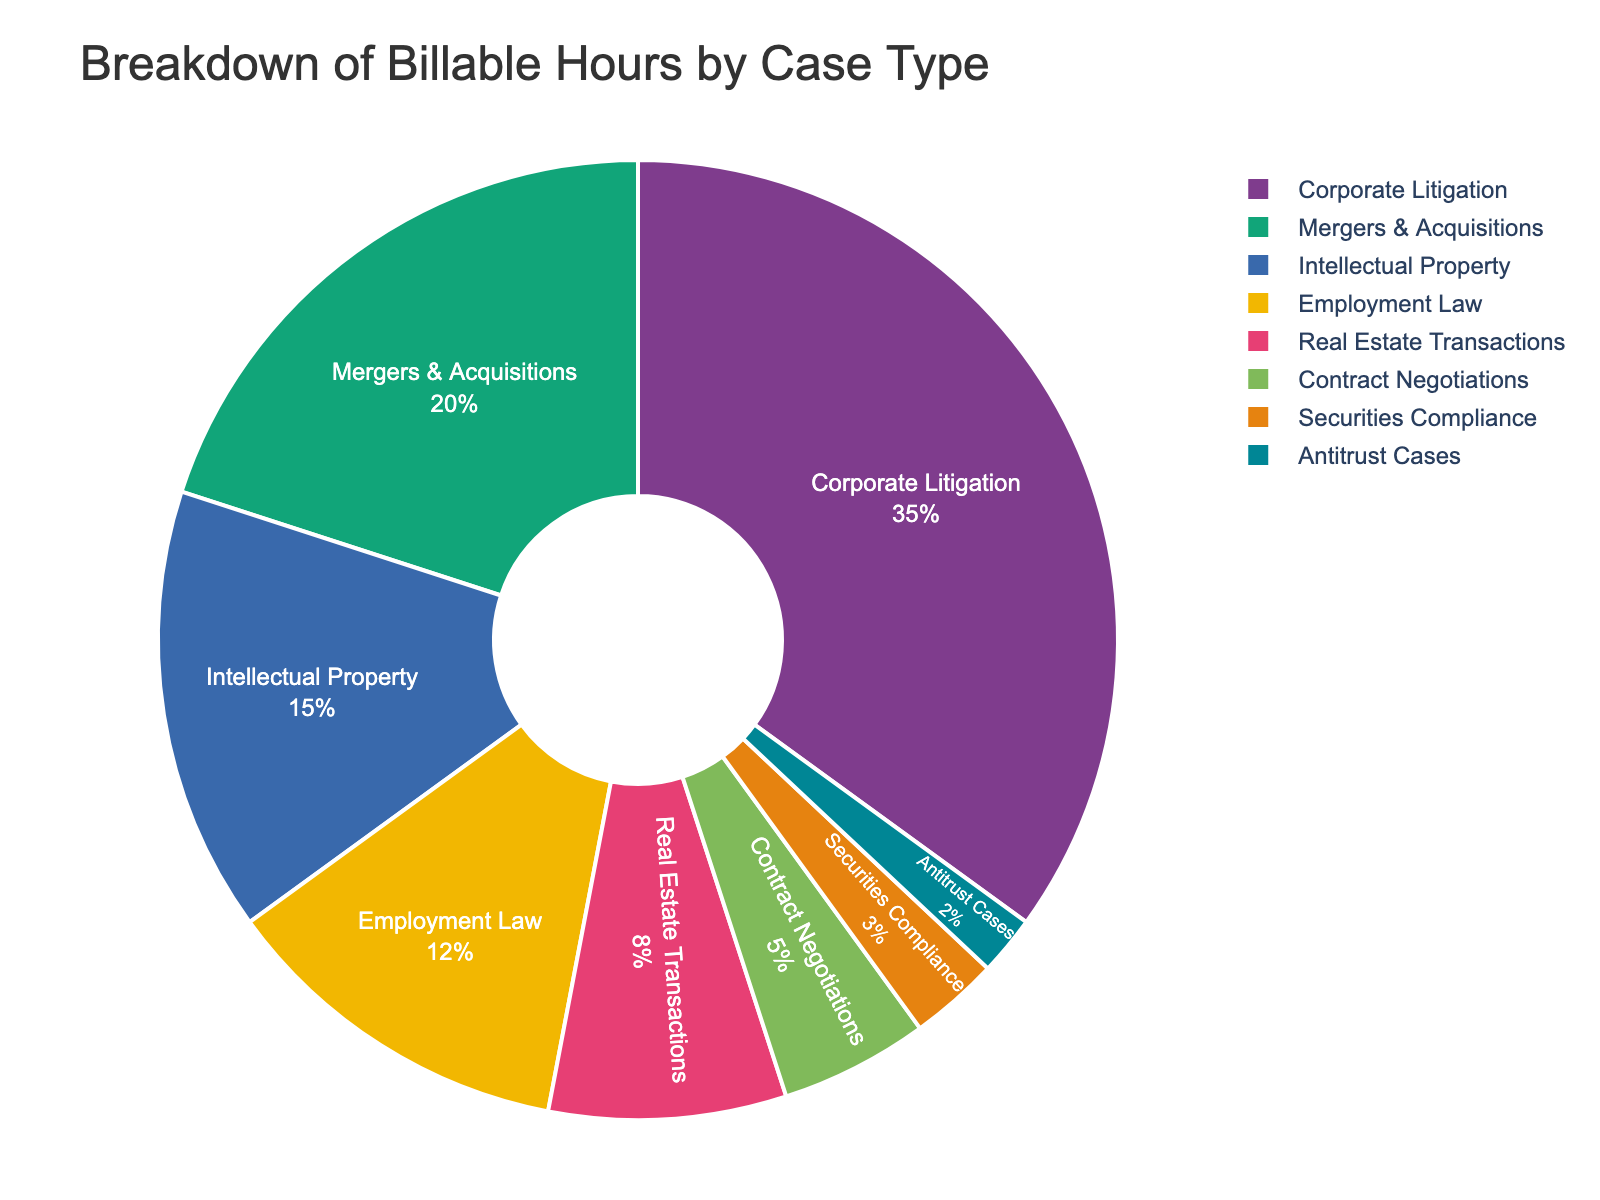What's the largest segment in the pie chart? By looking at the pie chart, the largest segment represents the case type with the highest billable hours percentage. Since "Corporate Litigation" has the largest portion in the pie chart at 35%, it is the largest segment.
Answer: Corporate Litigation What is the combined percentage for Real Estate Transactions, Contract Negotiations, and Securities Compliance? Add up the percentages for Real Estate Transactions (8%), Contract Negotiations (5%), and Securities Compliance (3%). 8 + 5 + 3 = 16.
Answer: 16% Which case type has more billable hours: Intellectual Property or Employment Law? By referring to the pie chart, Intellectual Property has 15% of billable hours, while Employment Law has 12%. Thus, Intellectual Property has more billable hours than Employment Law.
Answer: Intellectual Property What is the combined billable hours percentage for the top two case types? The top two case types by percentage are Corporate Litigation (35%) and Mergers & Acquisitions (20%). The combined percentage is 35 + 20 = 55.
Answer: 55% How many case types have a billable hours percentage of 10% or more? From the pie chart, the case types with 10% or more billable hours are Corporate Litigation (35%), Mergers & Acquisitions (20%), Intellectual Property (15%), and Employment Law (12%). There are 4 such case types.
Answer: 4 Which case type has the smallest segment in the pie chart? The smallest segment in the pie chart represents the case type with the lowest billable hours percentage. Antitrust Cases have the smallest segment with 2%.
Answer: Antitrust Cases Is the percentage of billable hours for Corporate Litigation greater than the combined percentage for Contract Negotiations, Securities Compliance, and Antitrust Cases? First, find the combined percentage for Contract Negotiations (5%), Securities Compliance (3%), and Antitrust Cases (2%). The sum is 5 + 3 + 2 = 10. Since Corporate Litigation is 35%, it is indeed greater than 10%.
Answer: Yes What is the average billable hours percentage for Intellectual Property, Employment Law, and Real Estate Transactions? Calculate the average by summing their percentages and dividing by the number of case types. (15 + 12 + 8) / 3 = 35 / 3 ≈ 11.67.
Answer: 11.67% What is the difference in billable hours percentage between the largest and smallest segments? The largest segment, Corporate Litigation, is 35%, and the smallest segment, Antitrust Cases, is 2%. The difference is 35 - 2 = 33.
Answer: 33 What is the total percentage of billable hours accounted for by the bottom three case types? The bottom three case types are Contract Negotiations (5%), Securities Compliance (3%), and Antitrust Cases (2%). The total is 5 + 3 + 2 = 10.
Answer: 10% 